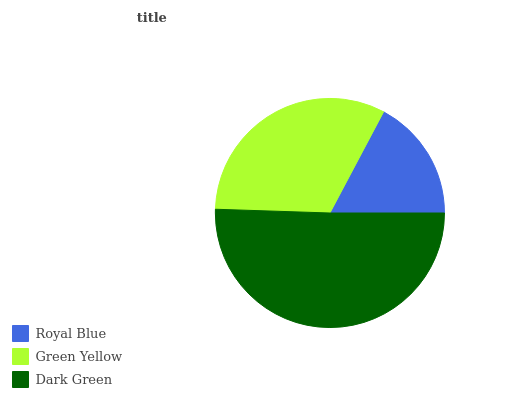Is Royal Blue the minimum?
Answer yes or no. Yes. Is Dark Green the maximum?
Answer yes or no. Yes. Is Green Yellow the minimum?
Answer yes or no. No. Is Green Yellow the maximum?
Answer yes or no. No. Is Green Yellow greater than Royal Blue?
Answer yes or no. Yes. Is Royal Blue less than Green Yellow?
Answer yes or no. Yes. Is Royal Blue greater than Green Yellow?
Answer yes or no. No. Is Green Yellow less than Royal Blue?
Answer yes or no. No. Is Green Yellow the high median?
Answer yes or no. Yes. Is Green Yellow the low median?
Answer yes or no. Yes. Is Royal Blue the high median?
Answer yes or no. No. Is Royal Blue the low median?
Answer yes or no. No. 